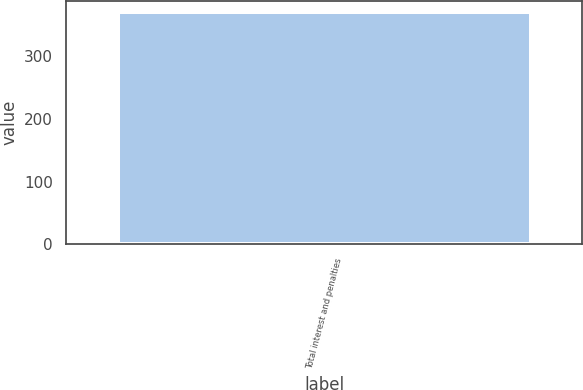Convert chart. <chart><loc_0><loc_0><loc_500><loc_500><bar_chart><fcel>Total interest and penalties<nl><fcel>370<nl></chart> 